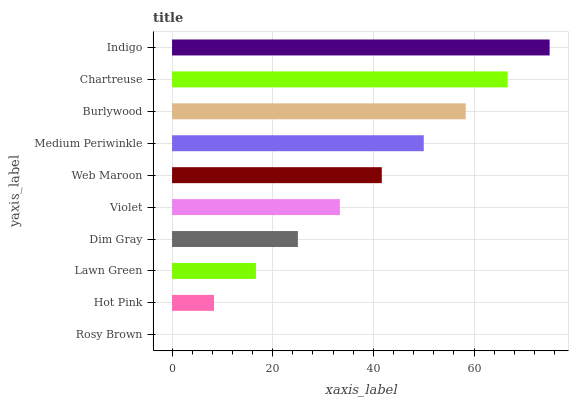Is Rosy Brown the minimum?
Answer yes or no. Yes. Is Indigo the maximum?
Answer yes or no. Yes. Is Hot Pink the minimum?
Answer yes or no. No. Is Hot Pink the maximum?
Answer yes or no. No. Is Hot Pink greater than Rosy Brown?
Answer yes or no. Yes. Is Rosy Brown less than Hot Pink?
Answer yes or no. Yes. Is Rosy Brown greater than Hot Pink?
Answer yes or no. No. Is Hot Pink less than Rosy Brown?
Answer yes or no. No. Is Web Maroon the high median?
Answer yes or no. Yes. Is Violet the low median?
Answer yes or no. Yes. Is Dim Gray the high median?
Answer yes or no. No. Is Indigo the low median?
Answer yes or no. No. 